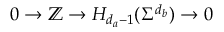Convert formula to latex. <formula><loc_0><loc_0><loc_500><loc_500>\begin{array} { r } { 0 \to \mathbb { Z } \to H _ { d _ { a } - 1 } ( \Sigma ^ { d _ { b } } ) \to 0 } \end{array}</formula> 